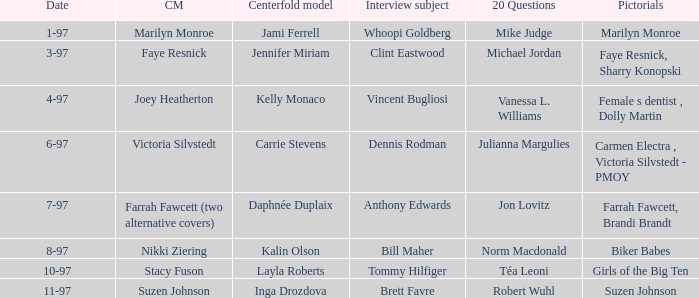Who was the centerfold model when a pictorial was done on marilyn monroe? Jami Ferrell. 